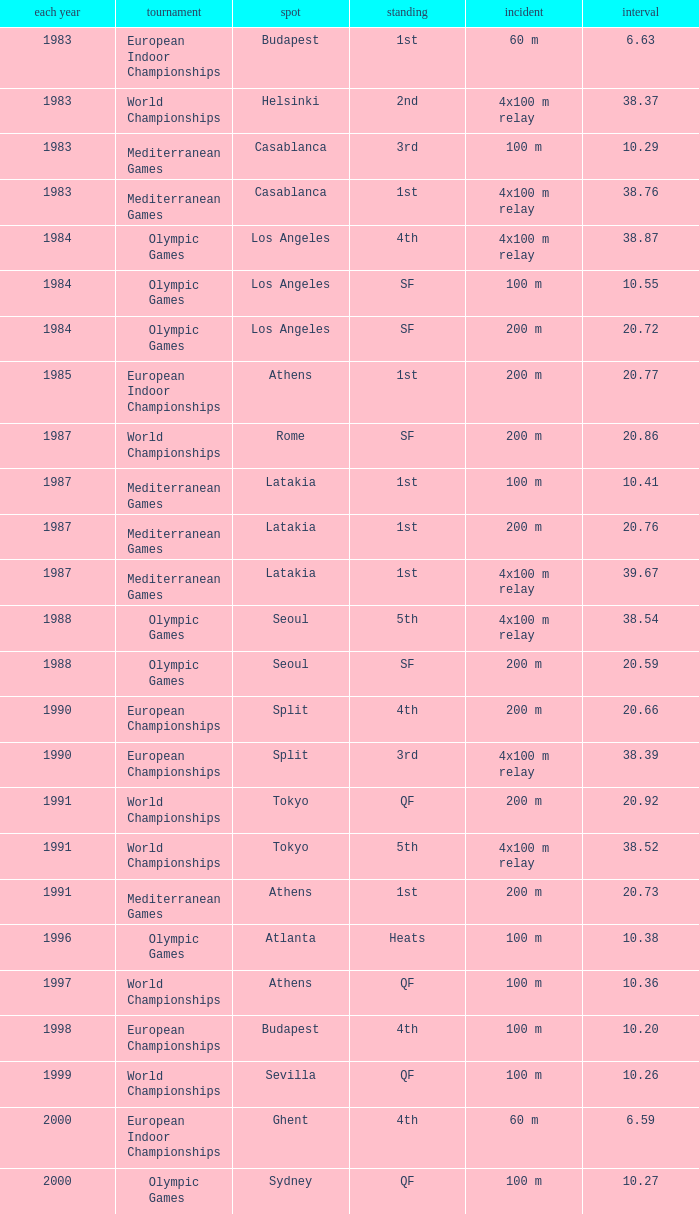What Position has a Time of 20.66? 4th. Could you help me parse every detail presented in this table? {'header': ['each year', 'tournament', 'spot', 'standing', 'incident', 'interval'], 'rows': [['1983', 'European Indoor Championships', 'Budapest', '1st', '60 m', '6.63'], ['1983', 'World Championships', 'Helsinki', '2nd', '4x100 m relay', '38.37'], ['1983', 'Mediterranean Games', 'Casablanca', '3rd', '100 m', '10.29'], ['1983', 'Mediterranean Games', 'Casablanca', '1st', '4x100 m relay', '38.76'], ['1984', 'Olympic Games', 'Los Angeles', '4th', '4x100 m relay', '38.87'], ['1984', 'Olympic Games', 'Los Angeles', 'SF', '100 m', '10.55'], ['1984', 'Olympic Games', 'Los Angeles', 'SF', '200 m', '20.72'], ['1985', 'European Indoor Championships', 'Athens', '1st', '200 m', '20.77'], ['1987', 'World Championships', 'Rome', 'SF', '200 m', '20.86'], ['1987', 'Mediterranean Games', 'Latakia', '1st', '100 m', '10.41'], ['1987', 'Mediterranean Games', 'Latakia', '1st', '200 m', '20.76'], ['1987', 'Mediterranean Games', 'Latakia', '1st', '4x100 m relay', '39.67'], ['1988', 'Olympic Games', 'Seoul', '5th', '4x100 m relay', '38.54'], ['1988', 'Olympic Games', 'Seoul', 'SF', '200 m', '20.59'], ['1990', 'European Championships', 'Split', '4th', '200 m', '20.66'], ['1990', 'European Championships', 'Split', '3rd', '4x100 m relay', '38.39'], ['1991', 'World Championships', 'Tokyo', 'QF', '200 m', '20.92'], ['1991', 'World Championships', 'Tokyo', '5th', '4x100 m relay', '38.52'], ['1991', 'Mediterranean Games', 'Athens', '1st', '200 m', '20.73'], ['1996', 'Olympic Games', 'Atlanta', 'Heats', '100 m', '10.38'], ['1997', 'World Championships', 'Athens', 'QF', '100 m', '10.36'], ['1998', 'European Championships', 'Budapest', '4th', '100 m', '10.20'], ['1999', 'World Championships', 'Sevilla', 'QF', '100 m', '10.26'], ['2000', 'European Indoor Championships', 'Ghent', '4th', '60 m', '6.59'], ['2000', 'Olympic Games', 'Sydney', 'QF', '100 m', '10.27']]} 